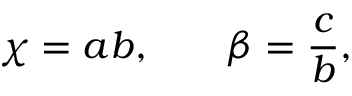<formula> <loc_0><loc_0><loc_500><loc_500>\chi = a b , \, \beta = \frac { c } { b } ,</formula> 